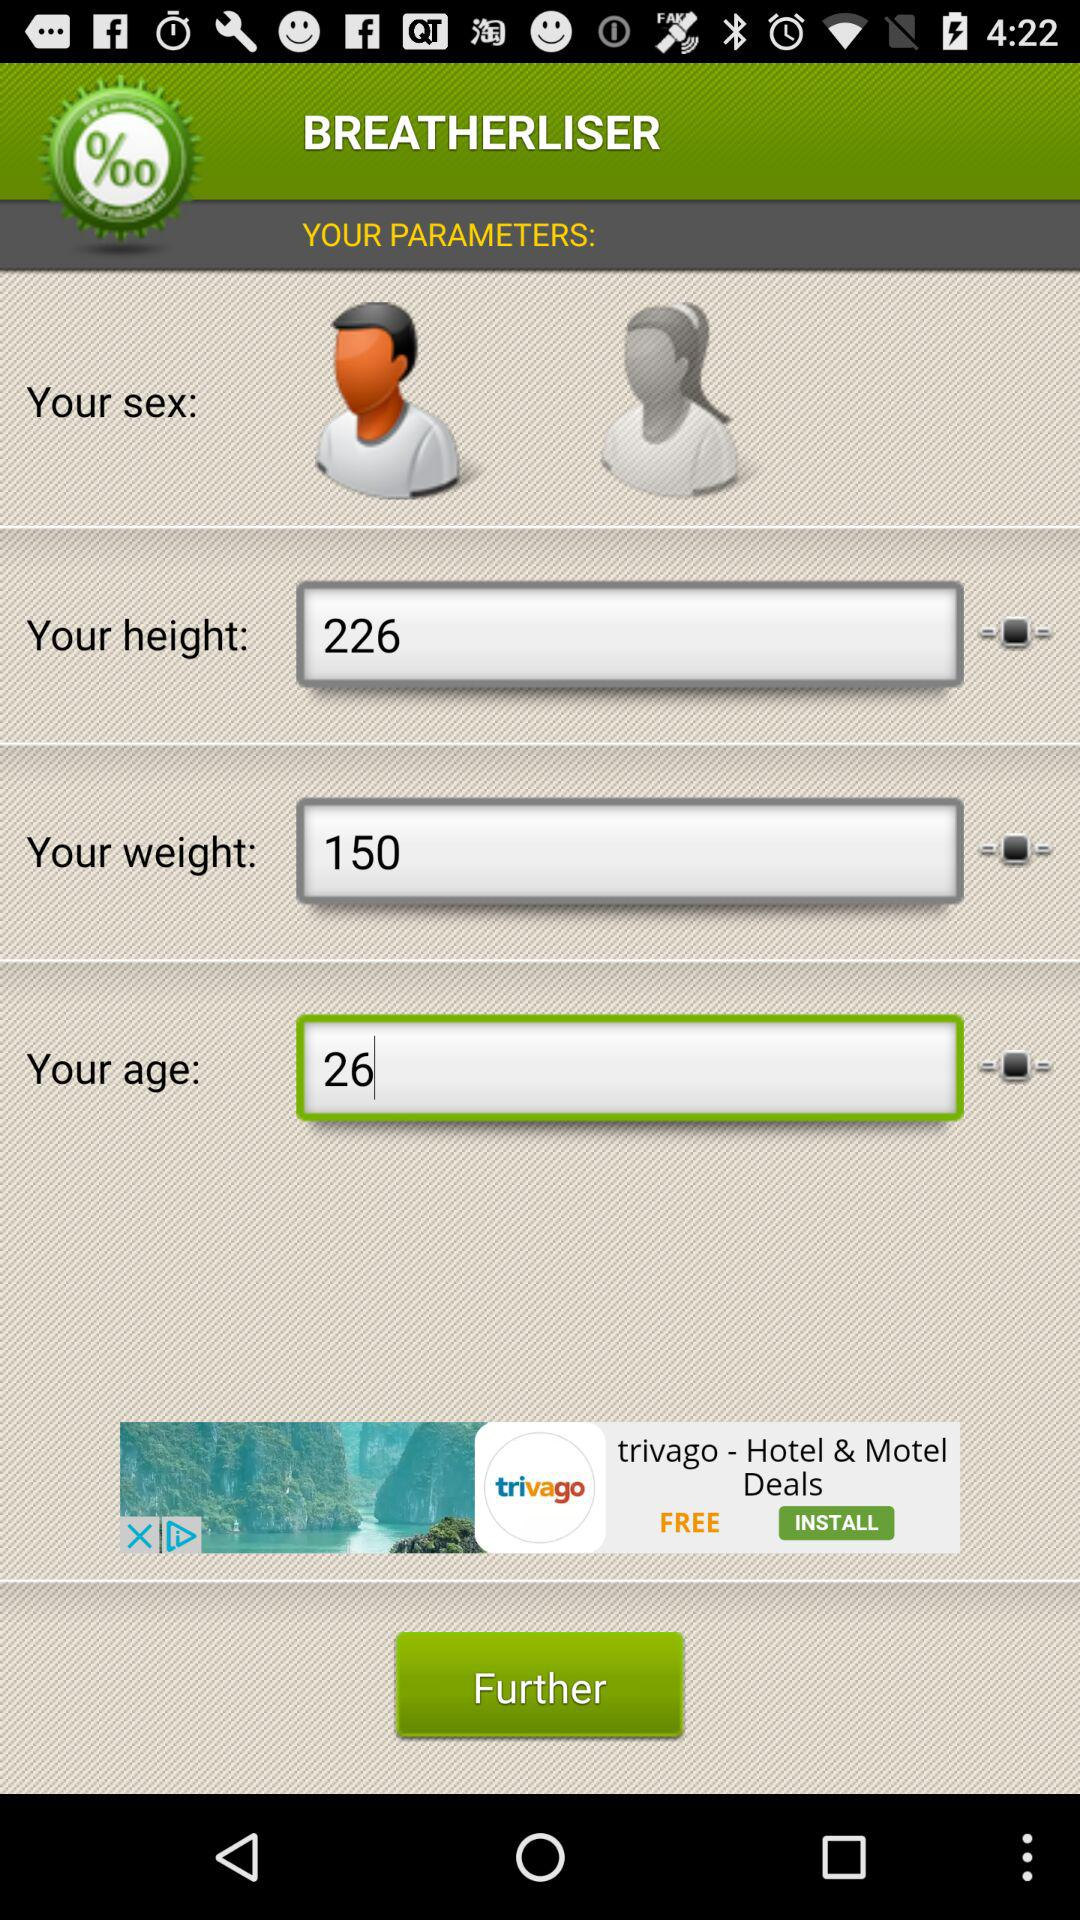What is the height? The height is 226. 